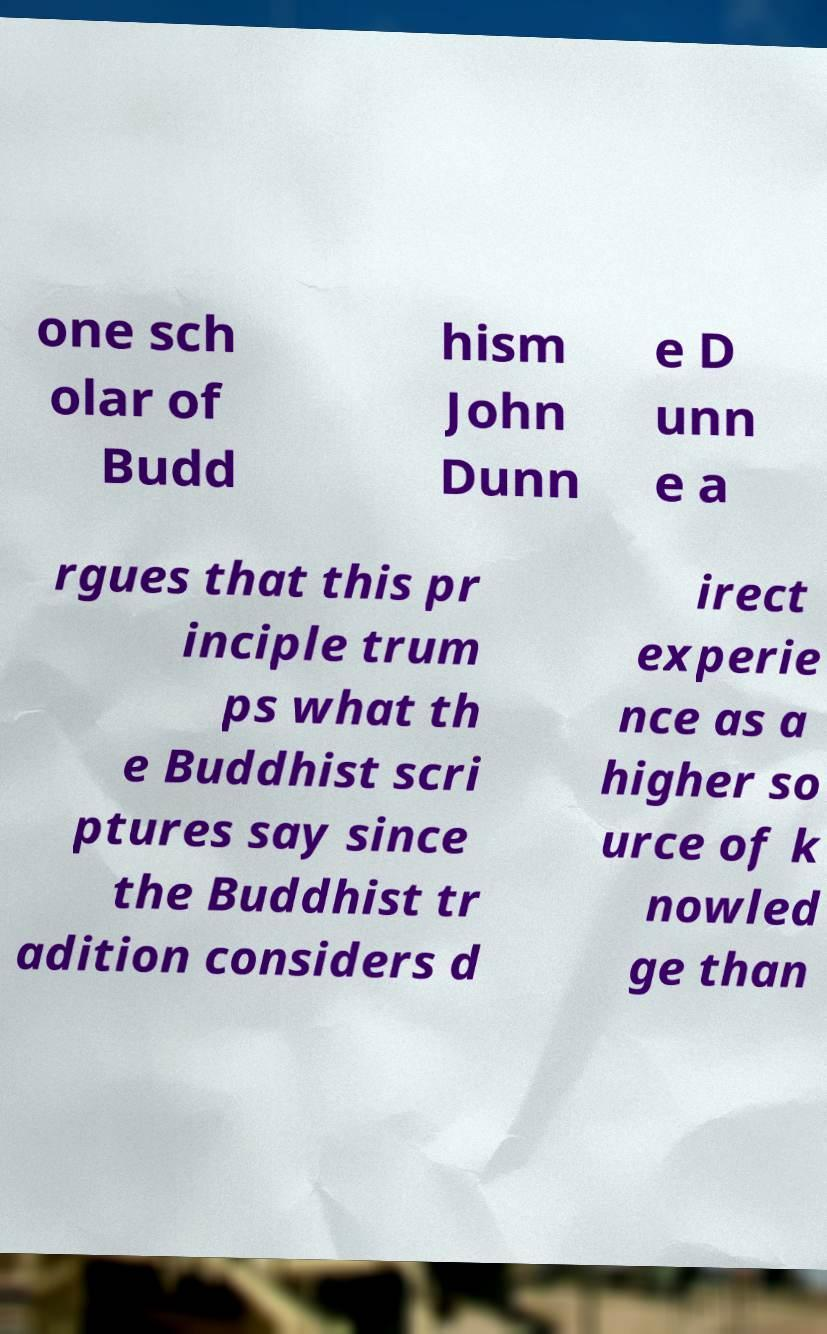Please read and relay the text visible in this image. What does it say? one sch olar of Budd hism John Dunn e D unn e a rgues that this pr inciple trum ps what th e Buddhist scri ptures say since the Buddhist tr adition considers d irect experie nce as a higher so urce of k nowled ge than 